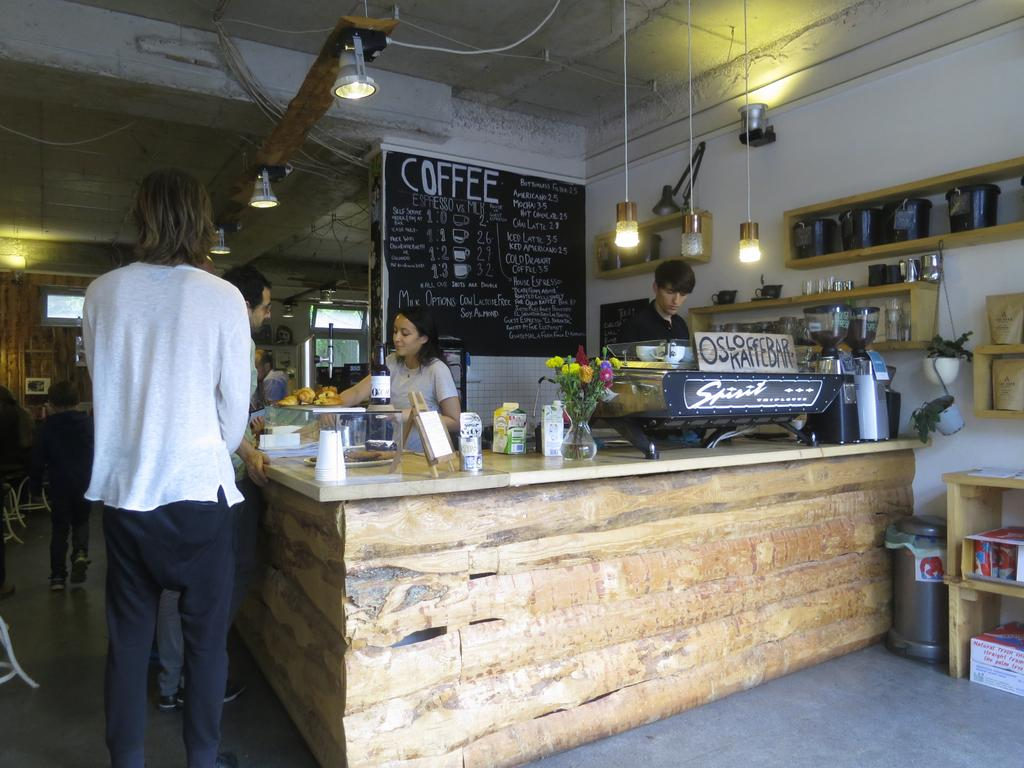What type of furniture is present in the image? There is a table in the image. What is placed on the table? There are objects on the table. Can you describe the people in the image? There are people standing in the image. What is the color of the poster in the image? There is a black color poster in the image. What can be seen providing illumination in the image? There are lights visible in the image. What country is depicted on the poster in the image? The provided facts do not mention any country being depicted on the poster, so it cannot be determined from the image. 